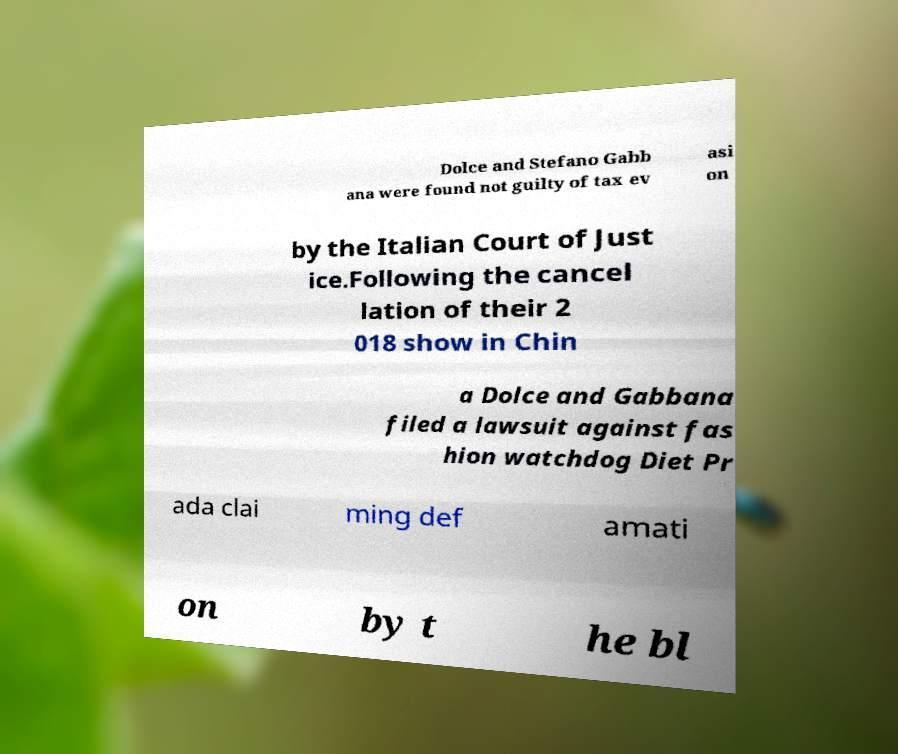Can you accurately transcribe the text from the provided image for me? Dolce and Stefano Gabb ana were found not guilty of tax ev asi on by the Italian Court of Just ice.Following the cancel lation of their 2 018 show in Chin a Dolce and Gabbana filed a lawsuit against fas hion watchdog Diet Pr ada clai ming def amati on by t he bl 